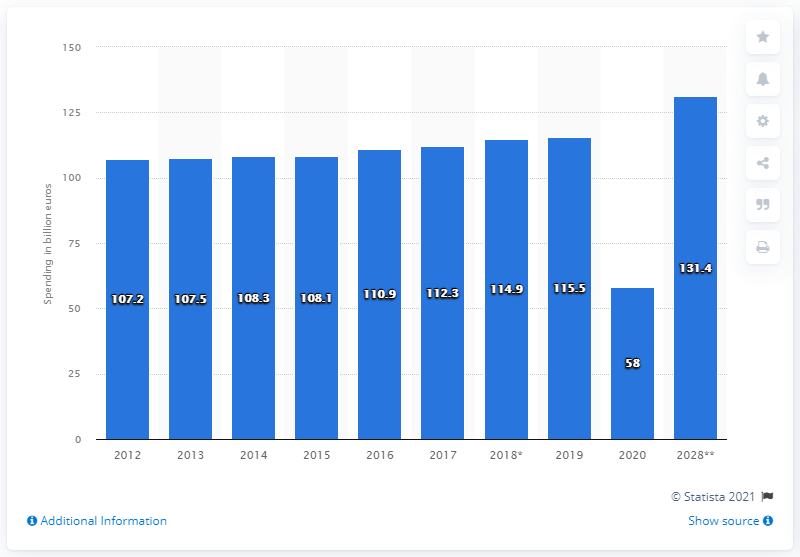What does the asterisk on the chart's 2018 data signify? The asterisk next to the 2018 figure on the chart typically denotes there's additional information or a specific note about that data point. It may indicate a revision of the data, an estimation, or a particular method of calculation that differs from other years. And what about the double asterisk on the 2028 figure? The double asterisk next to the 2028 figure suggests that the value is a projection or forecast, not actual recorded data. It implies that this number is based on predictions or trends and is subject to change as new data emerges closer to 2028. 